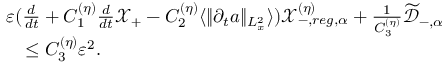Convert formula to latex. <formula><loc_0><loc_0><loc_500><loc_500>\begin{array} { r l } & { \varepsilon ( \frac { d } { d t } + C _ { 1 } ^ { ( \eta ) } \frac { d } { d t } \ m a t h s c r X _ { + } - C _ { 2 } ^ { ( \eta ) } \langle \| \partial _ { t } a \| _ { L _ { x } ^ { 2 } } \rangle ) \ m a t h s c r X _ { - , r e g , \alpha } ^ { ( \eta ) } + \frac { 1 } { C _ { 3 } ^ { ( \eta ) } } \widetilde { \ m a t h s c r D } _ { - , \alpha } } \\ & { \quad \leq C _ { 3 } ^ { ( \eta ) } \varepsilon ^ { 2 } . } \end{array}</formula> 